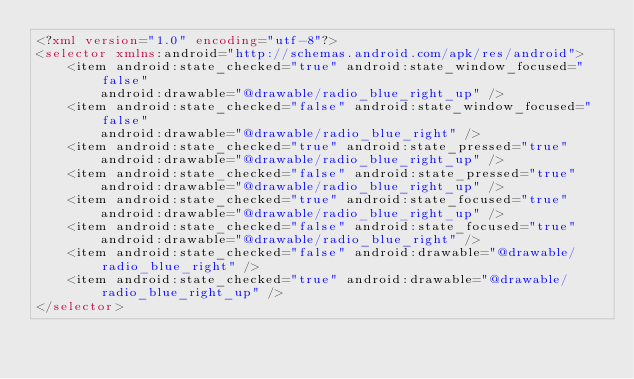<code> <loc_0><loc_0><loc_500><loc_500><_XML_><?xml version="1.0" encoding="utf-8"?>
<selector xmlns:android="http://schemas.android.com/apk/res/android">
    <item android:state_checked="true" android:state_window_focused="false"
        android:drawable="@drawable/radio_blue_right_up" />
    <item android:state_checked="false" android:state_window_focused="false"
        android:drawable="@drawable/radio_blue_right" />
    <item android:state_checked="true" android:state_pressed="true"
        android:drawable="@drawable/radio_blue_right_up" />
    <item android:state_checked="false" android:state_pressed="true"
        android:drawable="@drawable/radio_blue_right_up" />
    <item android:state_checked="true" android:state_focused="true"
        android:drawable="@drawable/radio_blue_right_up" />
    <item android:state_checked="false" android:state_focused="true"
        android:drawable="@drawable/radio_blue_right" />
    <item android:state_checked="false" android:drawable="@drawable/radio_blue_right" />
    <item android:state_checked="true" android:drawable="@drawable/radio_blue_right_up" />
</selector>
</code> 